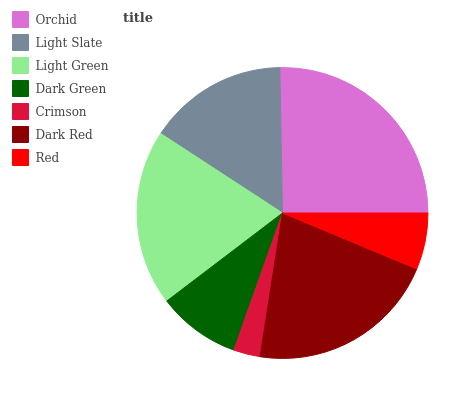Is Crimson the minimum?
Answer yes or no. Yes. Is Orchid the maximum?
Answer yes or no. Yes. Is Light Slate the minimum?
Answer yes or no. No. Is Light Slate the maximum?
Answer yes or no. No. Is Orchid greater than Light Slate?
Answer yes or no. Yes. Is Light Slate less than Orchid?
Answer yes or no. Yes. Is Light Slate greater than Orchid?
Answer yes or no. No. Is Orchid less than Light Slate?
Answer yes or no. No. Is Light Slate the high median?
Answer yes or no. Yes. Is Light Slate the low median?
Answer yes or no. Yes. Is Dark Green the high median?
Answer yes or no. No. Is Light Green the low median?
Answer yes or no. No. 